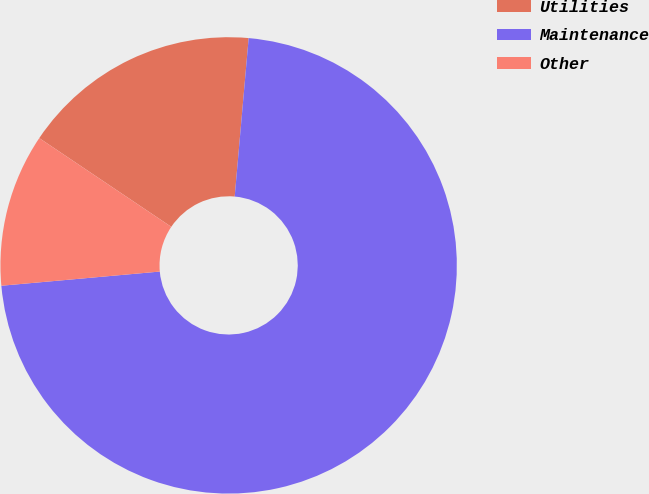Convert chart to OTSL. <chart><loc_0><loc_0><loc_500><loc_500><pie_chart><fcel>Utilities<fcel>Maintenance<fcel>Other<nl><fcel>16.98%<fcel>72.18%<fcel>10.84%<nl></chart> 